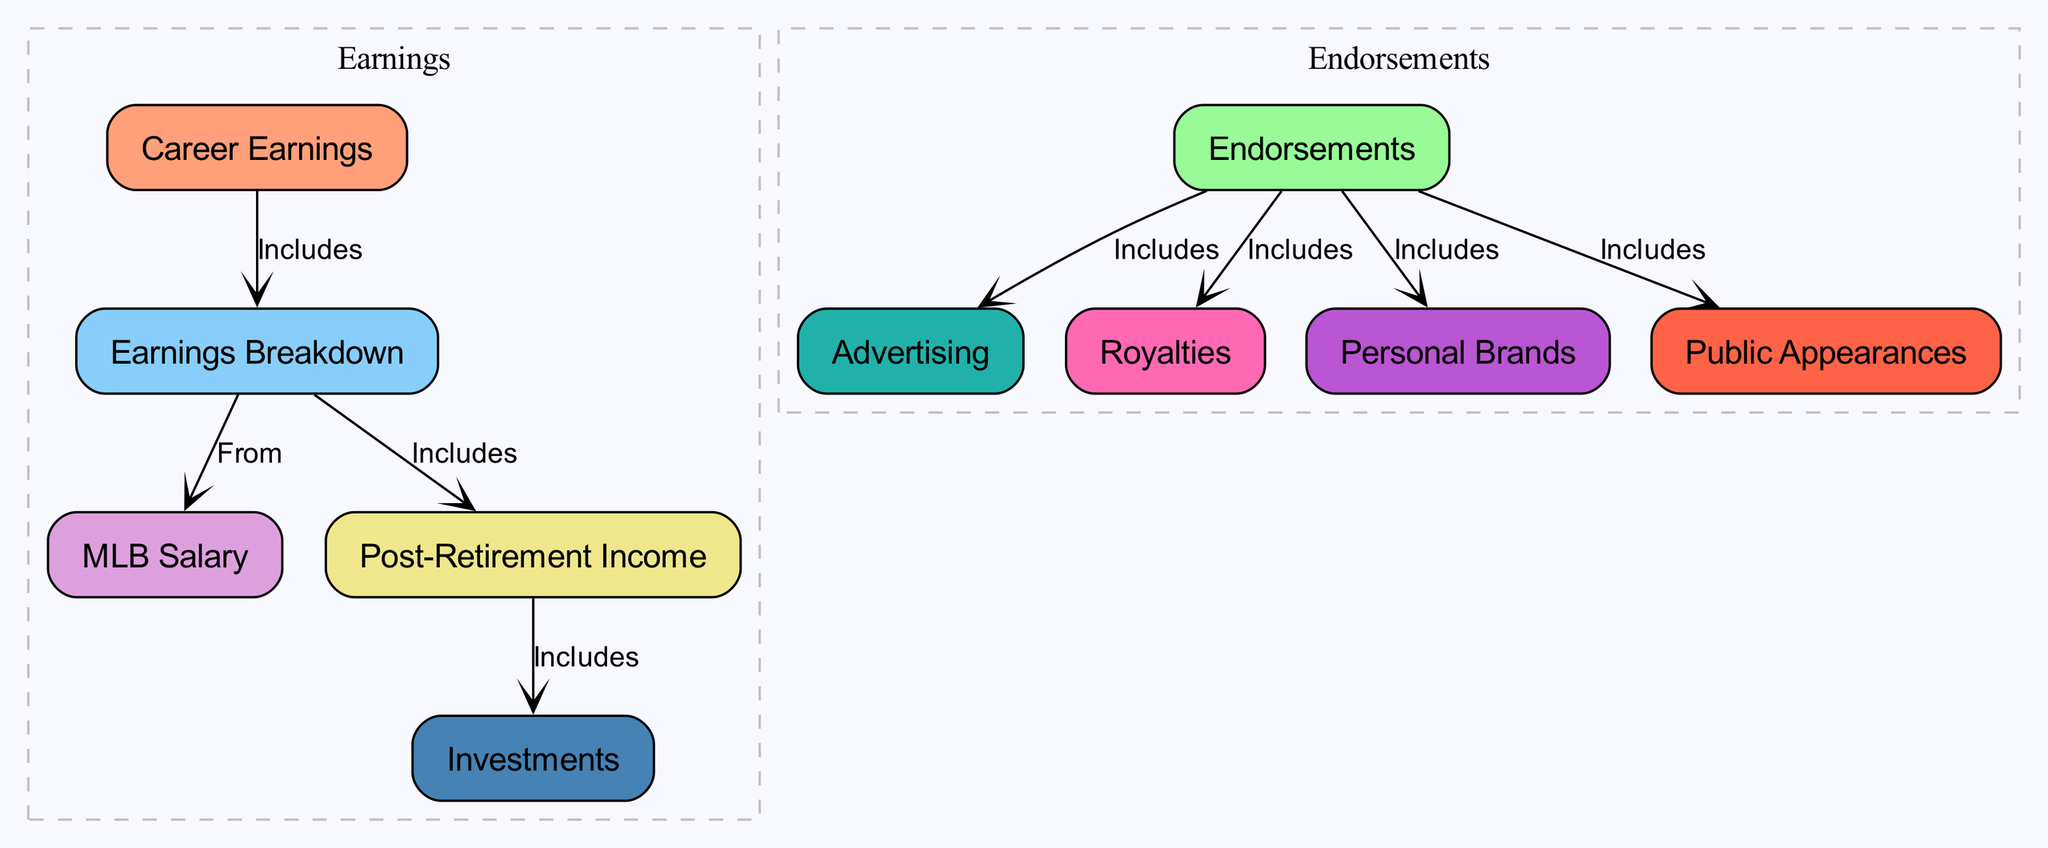What are the two main categories of financial aspects in Willie Mays's career? The diagram presents two main categories: Career Earnings and Endorsements. These categories encapsulate the primary sources of Mays's income throughout his career and beyond.
Answer: Career Earnings, Endorsements How many nodes are present in the diagram? The diagram contains ten nodes, representing various aspects of Willie Mays's earnings and endorsements. Each node highlights a specific element within the broader categories established.
Answer: 10 What specific type of income does post-retirement include? The "Post-Retirement Income" node includes "Investments." This indicates that part of Mays's financial gains after his active playing career comes from investment activities.
Answer: Investments What is included in the earnings breakdown? The "Earnings Breakdown" node includes two components: "MLB Salary" and "Post-Retirement Income." This delineates the sources from which Willie Mays's career earnings are derived.
Answer: MLB Salary, Post-Retirement Income How are endorsements categorized in the diagram? The endorsements are categorized into four components: Advertising, Royalties, Personal Brands, and Appearances. Each of these categories signifies a different area where Mays generated income through endorsements.
Answer: Advertising, Royalties, Personal Brands, Appearances Which node represents the total financial aspects of Willie Mays's career? The "Career Earnings" node represents the total financial aspects of Willie Mays’s career, as it encompasses the entire financial income derived from his professional life and beyond.
Answer: Career Earnings Which endorsement category is related to personal promotions? "Personal Brands" is the endorsement category related to personal promotions, as it signifies the branding and marketing efforts associated with Willie Mays as an individual, outside of team affiliations.
Answer: Personal Brands What flows into the post-retirement income node? The "Post-Retirement Income" node includes "Investments," indicating that income generated after his playing days is augmented by smart investment choices made by Mays.
Answer: Investments 